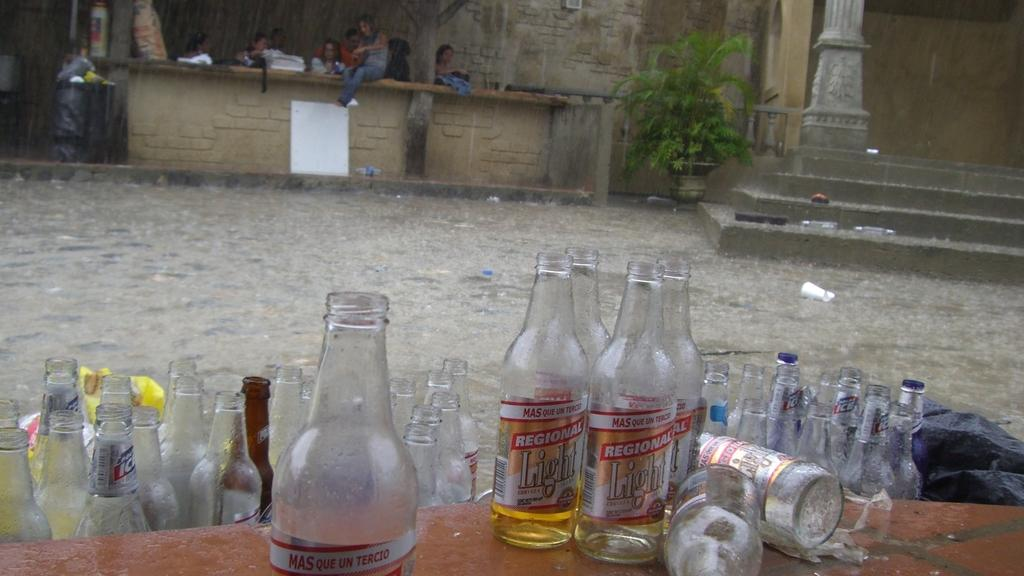<image>
Provide a brief description of the given image. Several bottles on a table including two which say Regional Light. 